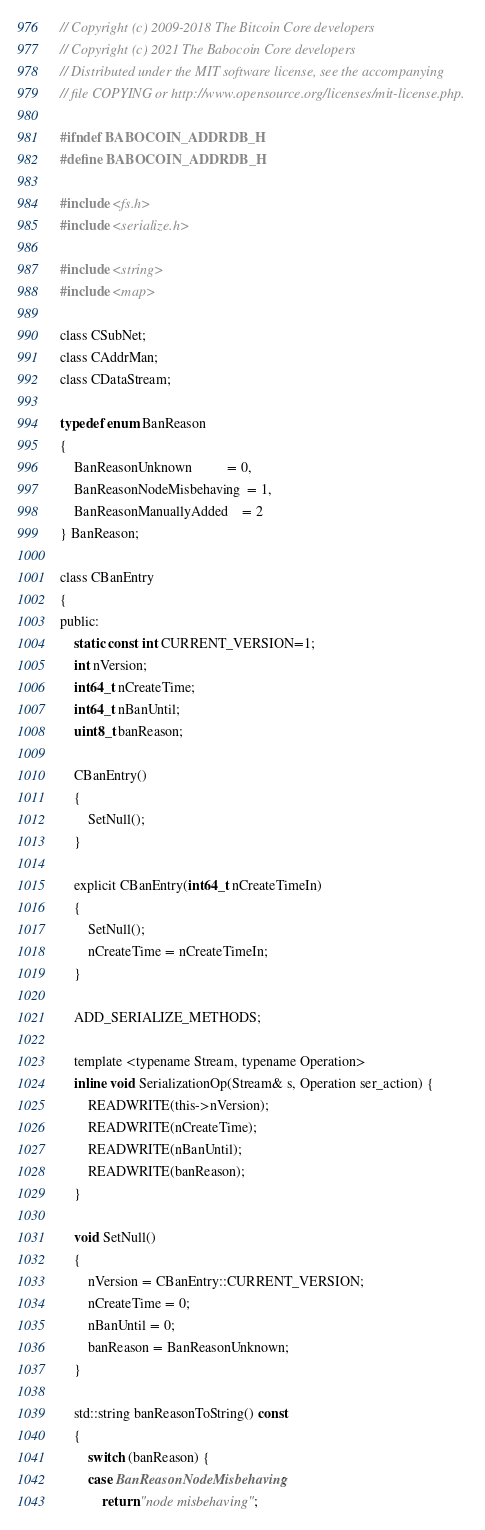<code> <loc_0><loc_0><loc_500><loc_500><_C_>// Copyright (c) 2009-2018 The Bitcoin Core developers
// Copyright (c) 2021 The Babocoin Core developers
// Distributed under the MIT software license, see the accompanying
// file COPYING or http://www.opensource.org/licenses/mit-license.php.

#ifndef BABOCOIN_ADDRDB_H
#define BABOCOIN_ADDRDB_H

#include <fs.h>
#include <serialize.h>

#include <string>
#include <map>

class CSubNet;
class CAddrMan;
class CDataStream;

typedef enum BanReason
{
    BanReasonUnknown          = 0,
    BanReasonNodeMisbehaving  = 1,
    BanReasonManuallyAdded    = 2
} BanReason;

class CBanEntry
{
public:
    static const int CURRENT_VERSION=1;
    int nVersion;
    int64_t nCreateTime;
    int64_t nBanUntil;
    uint8_t banReason;

    CBanEntry()
    {
        SetNull();
    }

    explicit CBanEntry(int64_t nCreateTimeIn)
    {
        SetNull();
        nCreateTime = nCreateTimeIn;
    }

    ADD_SERIALIZE_METHODS;

    template <typename Stream, typename Operation>
    inline void SerializationOp(Stream& s, Operation ser_action) {
        READWRITE(this->nVersion);
        READWRITE(nCreateTime);
        READWRITE(nBanUntil);
        READWRITE(banReason);
    }

    void SetNull()
    {
        nVersion = CBanEntry::CURRENT_VERSION;
        nCreateTime = 0;
        nBanUntil = 0;
        banReason = BanReasonUnknown;
    }

    std::string banReasonToString() const
    {
        switch (banReason) {
        case BanReasonNodeMisbehaving:
            return "node misbehaving";</code> 